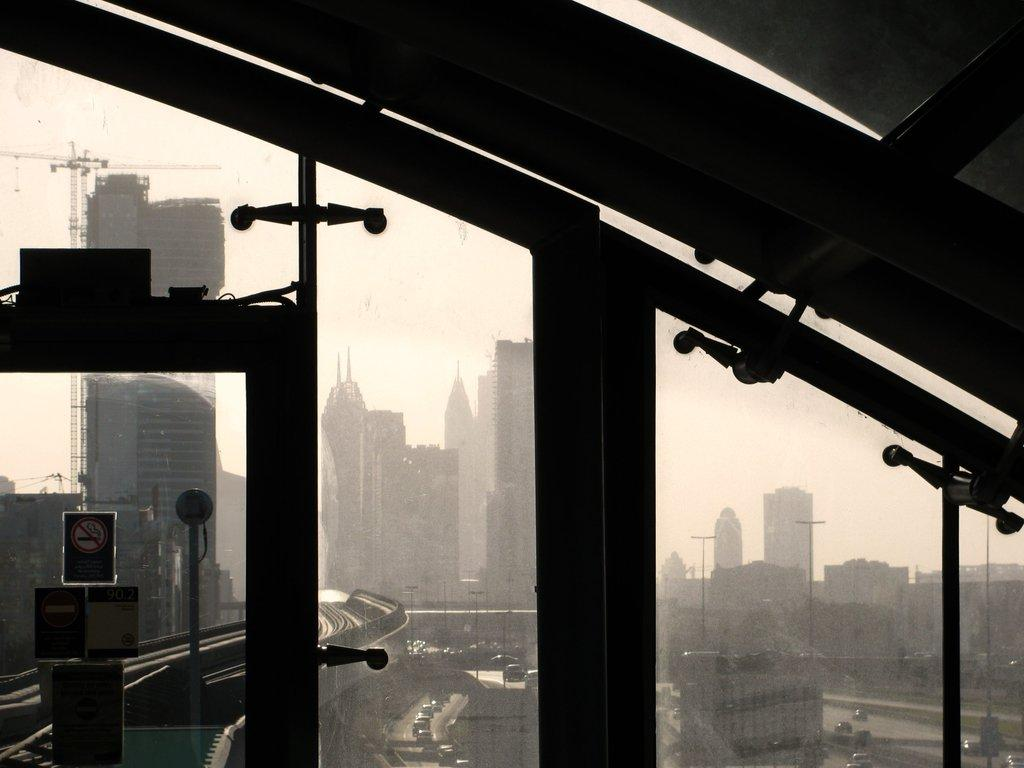What is featured on the poster in the image? The facts provided do not specify what is on the poster. What is inside the glass in the image? The facts provided do not specify what is inside the glass. What can be seen through the glass in the image? Poles, a board, buildings, vehicles, a crane, and the sky can be seen through the glass in the image. Where is the prison located in the image? There is no prison present in the image. Can you see a frog hopping on the board through the glass? There is no frog present in the image. 